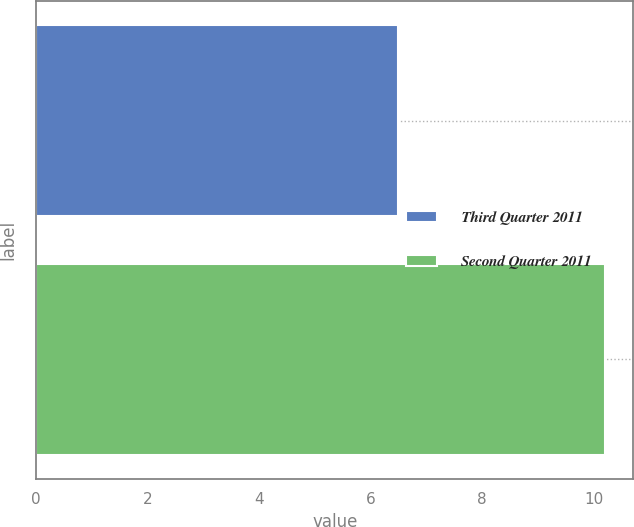Convert chart. <chart><loc_0><loc_0><loc_500><loc_500><bar_chart><fcel>Third Quarter 2011<fcel>Second Quarter 2011<nl><fcel>6.5<fcel>10.2<nl></chart> 